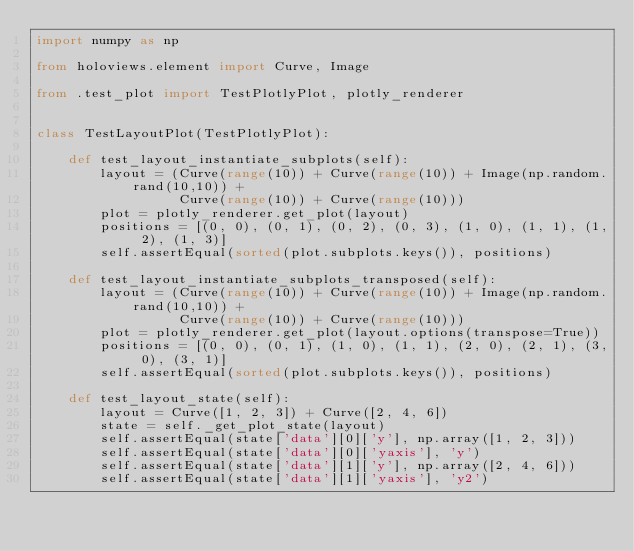<code> <loc_0><loc_0><loc_500><loc_500><_Python_>import numpy as np

from holoviews.element import Curve, Image

from .test_plot import TestPlotlyPlot, plotly_renderer


class TestLayoutPlot(TestPlotlyPlot):

    def test_layout_instantiate_subplots(self):
        layout = (Curve(range(10)) + Curve(range(10)) + Image(np.random.rand(10,10)) +
                  Curve(range(10)) + Curve(range(10)))
        plot = plotly_renderer.get_plot(layout)
        positions = [(0, 0), (0, 1), (0, 2), (0, 3), (1, 0), (1, 1), (1, 2), (1, 3)]
        self.assertEqual(sorted(plot.subplots.keys()), positions)

    def test_layout_instantiate_subplots_transposed(self):
        layout = (Curve(range(10)) + Curve(range(10)) + Image(np.random.rand(10,10)) +
                  Curve(range(10)) + Curve(range(10)))
        plot = plotly_renderer.get_plot(layout.options(transpose=True))
        positions = [(0, 0), (0, 1), (1, 0), (1, 1), (2, 0), (2, 1), (3, 0), (3, 1)]
        self.assertEqual(sorted(plot.subplots.keys()), positions)

    def test_layout_state(self):
        layout = Curve([1, 2, 3]) + Curve([2, 4, 6])
        state = self._get_plot_state(layout)
        self.assertEqual(state['data'][0]['y'], np.array([1, 2, 3]))
        self.assertEqual(state['data'][0]['yaxis'], 'y')
        self.assertEqual(state['data'][1]['y'], np.array([2, 4, 6]))
        self.assertEqual(state['data'][1]['yaxis'], 'y2')
</code> 